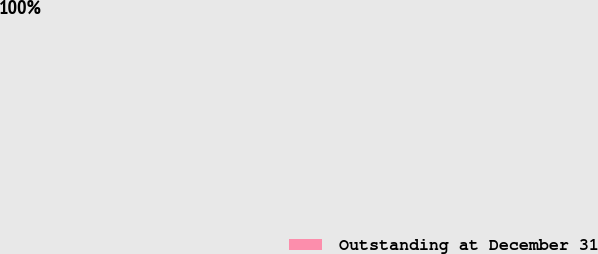Convert chart to OTSL. <chart><loc_0><loc_0><loc_500><loc_500><pie_chart><fcel>Outstanding at December 31<nl><fcel>100.0%<nl></chart> 